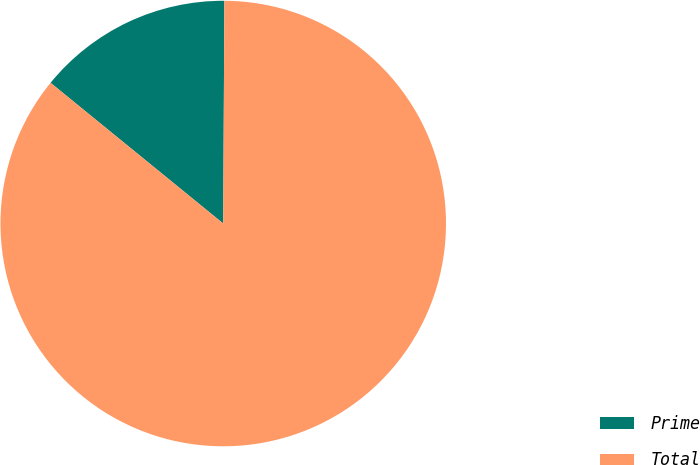Convert chart. <chart><loc_0><loc_0><loc_500><loc_500><pie_chart><fcel>Prime<fcel>Total<nl><fcel>14.2%<fcel>85.8%<nl></chart> 